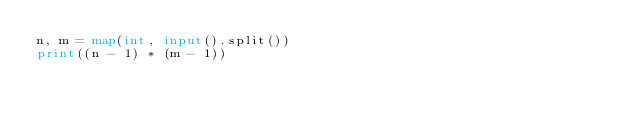Convert code to text. <code><loc_0><loc_0><loc_500><loc_500><_Python_>n, m = map(int, input().split())
print((n - 1) * (m - 1))
</code> 